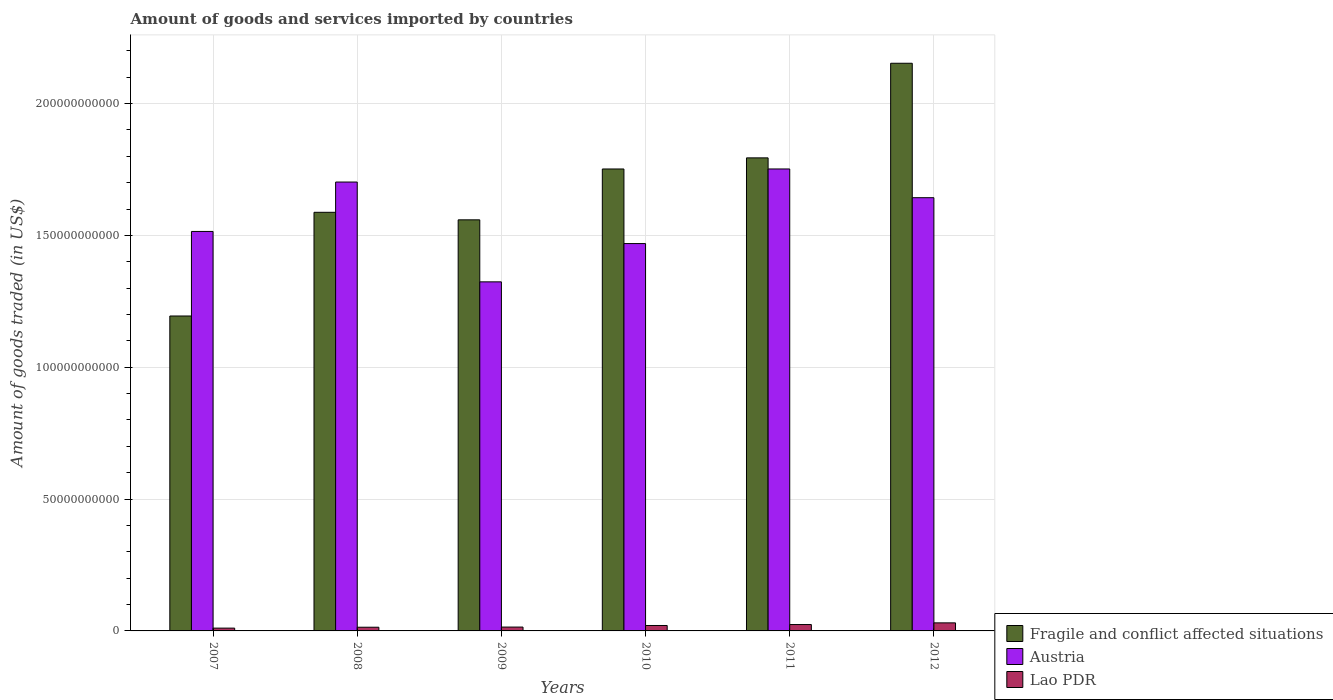How many groups of bars are there?
Make the answer very short. 6. How many bars are there on the 3rd tick from the left?
Provide a short and direct response. 3. What is the label of the 6th group of bars from the left?
Offer a very short reply. 2012. In how many cases, is the number of bars for a given year not equal to the number of legend labels?
Your response must be concise. 0. What is the total amount of goods and services imported in Fragile and conflict affected situations in 2010?
Offer a very short reply. 1.75e+11. Across all years, what is the maximum total amount of goods and services imported in Austria?
Your answer should be very brief. 1.75e+11. Across all years, what is the minimum total amount of goods and services imported in Fragile and conflict affected situations?
Provide a succinct answer. 1.19e+11. In which year was the total amount of goods and services imported in Lao PDR maximum?
Provide a succinct answer. 2012. In which year was the total amount of goods and services imported in Fragile and conflict affected situations minimum?
Make the answer very short. 2007. What is the total total amount of goods and services imported in Fragile and conflict affected situations in the graph?
Offer a very short reply. 1.00e+12. What is the difference between the total amount of goods and services imported in Fragile and conflict affected situations in 2009 and that in 2010?
Make the answer very short. -1.93e+1. What is the difference between the total amount of goods and services imported in Fragile and conflict affected situations in 2011 and the total amount of goods and services imported in Lao PDR in 2010?
Your response must be concise. 1.77e+11. What is the average total amount of goods and services imported in Austria per year?
Your answer should be compact. 1.57e+11. In the year 2012, what is the difference between the total amount of goods and services imported in Lao PDR and total amount of goods and services imported in Fragile and conflict affected situations?
Provide a short and direct response. -2.12e+11. In how many years, is the total amount of goods and services imported in Austria greater than 150000000000 US$?
Keep it short and to the point. 4. What is the ratio of the total amount of goods and services imported in Fragile and conflict affected situations in 2010 to that in 2012?
Your answer should be very brief. 0.81. What is the difference between the highest and the second highest total amount of goods and services imported in Fragile and conflict affected situations?
Your answer should be very brief. 3.59e+1. What is the difference between the highest and the lowest total amount of goods and services imported in Fragile and conflict affected situations?
Your answer should be very brief. 9.59e+1. In how many years, is the total amount of goods and services imported in Austria greater than the average total amount of goods and services imported in Austria taken over all years?
Provide a short and direct response. 3. Is the sum of the total amount of goods and services imported in Fragile and conflict affected situations in 2010 and 2011 greater than the maximum total amount of goods and services imported in Lao PDR across all years?
Offer a terse response. Yes. What does the 2nd bar from the left in 2012 represents?
Keep it short and to the point. Austria. What does the 1st bar from the right in 2009 represents?
Ensure brevity in your answer.  Lao PDR. How many bars are there?
Give a very brief answer. 18. Are the values on the major ticks of Y-axis written in scientific E-notation?
Ensure brevity in your answer.  No. Does the graph contain any zero values?
Your answer should be compact. No. Does the graph contain grids?
Your answer should be compact. Yes. How are the legend labels stacked?
Provide a short and direct response. Vertical. What is the title of the graph?
Keep it short and to the point. Amount of goods and services imported by countries. What is the label or title of the X-axis?
Provide a short and direct response. Years. What is the label or title of the Y-axis?
Give a very brief answer. Amount of goods traded (in US$). What is the Amount of goods traded (in US$) of Fragile and conflict affected situations in 2007?
Offer a terse response. 1.19e+11. What is the Amount of goods traded (in US$) in Austria in 2007?
Your response must be concise. 1.52e+11. What is the Amount of goods traded (in US$) in Lao PDR in 2007?
Your answer should be compact. 1.06e+09. What is the Amount of goods traded (in US$) of Fragile and conflict affected situations in 2008?
Your answer should be very brief. 1.59e+11. What is the Amount of goods traded (in US$) of Austria in 2008?
Make the answer very short. 1.70e+11. What is the Amount of goods traded (in US$) of Lao PDR in 2008?
Give a very brief answer. 1.40e+09. What is the Amount of goods traded (in US$) of Fragile and conflict affected situations in 2009?
Your answer should be very brief. 1.56e+11. What is the Amount of goods traded (in US$) of Austria in 2009?
Your answer should be compact. 1.32e+11. What is the Amount of goods traded (in US$) in Lao PDR in 2009?
Your answer should be compact. 1.46e+09. What is the Amount of goods traded (in US$) of Fragile and conflict affected situations in 2010?
Provide a short and direct response. 1.75e+11. What is the Amount of goods traded (in US$) in Austria in 2010?
Make the answer very short. 1.47e+11. What is the Amount of goods traded (in US$) of Lao PDR in 2010?
Make the answer very short. 2.06e+09. What is the Amount of goods traded (in US$) of Fragile and conflict affected situations in 2011?
Offer a terse response. 1.79e+11. What is the Amount of goods traded (in US$) in Austria in 2011?
Your answer should be compact. 1.75e+11. What is the Amount of goods traded (in US$) in Lao PDR in 2011?
Your answer should be compact. 2.42e+09. What is the Amount of goods traded (in US$) of Fragile and conflict affected situations in 2012?
Offer a terse response. 2.15e+11. What is the Amount of goods traded (in US$) of Austria in 2012?
Your answer should be very brief. 1.64e+11. What is the Amount of goods traded (in US$) in Lao PDR in 2012?
Ensure brevity in your answer.  3.06e+09. Across all years, what is the maximum Amount of goods traded (in US$) in Fragile and conflict affected situations?
Provide a succinct answer. 2.15e+11. Across all years, what is the maximum Amount of goods traded (in US$) in Austria?
Provide a short and direct response. 1.75e+11. Across all years, what is the maximum Amount of goods traded (in US$) of Lao PDR?
Your answer should be compact. 3.06e+09. Across all years, what is the minimum Amount of goods traded (in US$) in Fragile and conflict affected situations?
Keep it short and to the point. 1.19e+11. Across all years, what is the minimum Amount of goods traded (in US$) of Austria?
Provide a short and direct response. 1.32e+11. Across all years, what is the minimum Amount of goods traded (in US$) in Lao PDR?
Make the answer very short. 1.06e+09. What is the total Amount of goods traded (in US$) of Fragile and conflict affected situations in the graph?
Give a very brief answer. 1.00e+12. What is the total Amount of goods traded (in US$) in Austria in the graph?
Offer a very short reply. 9.41e+11. What is the total Amount of goods traded (in US$) of Lao PDR in the graph?
Keep it short and to the point. 1.15e+1. What is the difference between the Amount of goods traded (in US$) in Fragile and conflict affected situations in 2007 and that in 2008?
Keep it short and to the point. -3.93e+1. What is the difference between the Amount of goods traded (in US$) in Austria in 2007 and that in 2008?
Your response must be concise. -1.87e+1. What is the difference between the Amount of goods traded (in US$) of Lao PDR in 2007 and that in 2008?
Offer a terse response. -3.39e+08. What is the difference between the Amount of goods traded (in US$) of Fragile and conflict affected situations in 2007 and that in 2009?
Make the answer very short. -3.65e+1. What is the difference between the Amount of goods traded (in US$) in Austria in 2007 and that in 2009?
Your response must be concise. 1.91e+1. What is the difference between the Amount of goods traded (in US$) of Lao PDR in 2007 and that in 2009?
Give a very brief answer. -3.96e+08. What is the difference between the Amount of goods traded (in US$) in Fragile and conflict affected situations in 2007 and that in 2010?
Your answer should be very brief. -5.58e+1. What is the difference between the Amount of goods traded (in US$) in Austria in 2007 and that in 2010?
Ensure brevity in your answer.  4.60e+09. What is the difference between the Amount of goods traded (in US$) of Lao PDR in 2007 and that in 2010?
Offer a very short reply. -9.96e+08. What is the difference between the Amount of goods traded (in US$) in Fragile and conflict affected situations in 2007 and that in 2011?
Ensure brevity in your answer.  -6.00e+1. What is the difference between the Amount of goods traded (in US$) in Austria in 2007 and that in 2011?
Offer a terse response. -2.37e+1. What is the difference between the Amount of goods traded (in US$) of Lao PDR in 2007 and that in 2011?
Give a very brief answer. -1.36e+09. What is the difference between the Amount of goods traded (in US$) in Fragile and conflict affected situations in 2007 and that in 2012?
Your answer should be compact. -9.59e+1. What is the difference between the Amount of goods traded (in US$) in Austria in 2007 and that in 2012?
Keep it short and to the point. -1.28e+1. What is the difference between the Amount of goods traded (in US$) in Lao PDR in 2007 and that in 2012?
Ensure brevity in your answer.  -1.99e+09. What is the difference between the Amount of goods traded (in US$) of Fragile and conflict affected situations in 2008 and that in 2009?
Provide a short and direct response. 2.86e+09. What is the difference between the Amount of goods traded (in US$) of Austria in 2008 and that in 2009?
Make the answer very short. 3.79e+1. What is the difference between the Amount of goods traded (in US$) in Lao PDR in 2008 and that in 2009?
Keep it short and to the point. -5.79e+07. What is the difference between the Amount of goods traded (in US$) of Fragile and conflict affected situations in 2008 and that in 2010?
Your answer should be compact. -1.64e+1. What is the difference between the Amount of goods traded (in US$) of Austria in 2008 and that in 2010?
Your response must be concise. 2.33e+1. What is the difference between the Amount of goods traded (in US$) in Lao PDR in 2008 and that in 2010?
Provide a short and direct response. -6.57e+08. What is the difference between the Amount of goods traded (in US$) of Fragile and conflict affected situations in 2008 and that in 2011?
Offer a terse response. -2.06e+1. What is the difference between the Amount of goods traded (in US$) in Austria in 2008 and that in 2011?
Ensure brevity in your answer.  -4.96e+09. What is the difference between the Amount of goods traded (in US$) in Lao PDR in 2008 and that in 2011?
Give a very brief answer. -1.02e+09. What is the difference between the Amount of goods traded (in US$) in Fragile and conflict affected situations in 2008 and that in 2012?
Give a very brief answer. -5.65e+1. What is the difference between the Amount of goods traded (in US$) of Austria in 2008 and that in 2012?
Make the answer very short. 5.94e+09. What is the difference between the Amount of goods traded (in US$) of Lao PDR in 2008 and that in 2012?
Give a very brief answer. -1.65e+09. What is the difference between the Amount of goods traded (in US$) in Fragile and conflict affected situations in 2009 and that in 2010?
Provide a short and direct response. -1.93e+1. What is the difference between the Amount of goods traded (in US$) of Austria in 2009 and that in 2010?
Offer a very short reply. -1.45e+1. What is the difference between the Amount of goods traded (in US$) in Lao PDR in 2009 and that in 2010?
Offer a terse response. -5.99e+08. What is the difference between the Amount of goods traded (in US$) of Fragile and conflict affected situations in 2009 and that in 2011?
Provide a short and direct response. -2.35e+1. What is the difference between the Amount of goods traded (in US$) in Austria in 2009 and that in 2011?
Your answer should be very brief. -4.28e+1. What is the difference between the Amount of goods traded (in US$) in Lao PDR in 2009 and that in 2011?
Ensure brevity in your answer.  -9.62e+08. What is the difference between the Amount of goods traded (in US$) of Fragile and conflict affected situations in 2009 and that in 2012?
Provide a short and direct response. -5.94e+1. What is the difference between the Amount of goods traded (in US$) of Austria in 2009 and that in 2012?
Provide a succinct answer. -3.19e+1. What is the difference between the Amount of goods traded (in US$) of Lao PDR in 2009 and that in 2012?
Make the answer very short. -1.59e+09. What is the difference between the Amount of goods traded (in US$) of Fragile and conflict affected situations in 2010 and that in 2011?
Give a very brief answer. -4.21e+09. What is the difference between the Amount of goods traded (in US$) in Austria in 2010 and that in 2011?
Provide a short and direct response. -2.83e+1. What is the difference between the Amount of goods traded (in US$) of Lao PDR in 2010 and that in 2011?
Give a very brief answer. -3.62e+08. What is the difference between the Amount of goods traded (in US$) in Fragile and conflict affected situations in 2010 and that in 2012?
Your response must be concise. -4.01e+1. What is the difference between the Amount of goods traded (in US$) in Austria in 2010 and that in 2012?
Provide a short and direct response. -1.74e+1. What is the difference between the Amount of goods traded (in US$) of Lao PDR in 2010 and that in 2012?
Make the answer very short. -9.95e+08. What is the difference between the Amount of goods traded (in US$) of Fragile and conflict affected situations in 2011 and that in 2012?
Make the answer very short. -3.59e+1. What is the difference between the Amount of goods traded (in US$) in Austria in 2011 and that in 2012?
Your answer should be very brief. 1.09e+1. What is the difference between the Amount of goods traded (in US$) of Lao PDR in 2011 and that in 2012?
Keep it short and to the point. -6.32e+08. What is the difference between the Amount of goods traded (in US$) of Fragile and conflict affected situations in 2007 and the Amount of goods traded (in US$) of Austria in 2008?
Offer a terse response. -5.08e+1. What is the difference between the Amount of goods traded (in US$) in Fragile and conflict affected situations in 2007 and the Amount of goods traded (in US$) in Lao PDR in 2008?
Your response must be concise. 1.18e+11. What is the difference between the Amount of goods traded (in US$) in Austria in 2007 and the Amount of goods traded (in US$) in Lao PDR in 2008?
Offer a very short reply. 1.50e+11. What is the difference between the Amount of goods traded (in US$) of Fragile and conflict affected situations in 2007 and the Amount of goods traded (in US$) of Austria in 2009?
Provide a succinct answer. -1.29e+1. What is the difference between the Amount of goods traded (in US$) in Fragile and conflict affected situations in 2007 and the Amount of goods traded (in US$) in Lao PDR in 2009?
Keep it short and to the point. 1.18e+11. What is the difference between the Amount of goods traded (in US$) in Austria in 2007 and the Amount of goods traded (in US$) in Lao PDR in 2009?
Give a very brief answer. 1.50e+11. What is the difference between the Amount of goods traded (in US$) in Fragile and conflict affected situations in 2007 and the Amount of goods traded (in US$) in Austria in 2010?
Keep it short and to the point. -2.75e+1. What is the difference between the Amount of goods traded (in US$) of Fragile and conflict affected situations in 2007 and the Amount of goods traded (in US$) of Lao PDR in 2010?
Your answer should be compact. 1.17e+11. What is the difference between the Amount of goods traded (in US$) in Austria in 2007 and the Amount of goods traded (in US$) in Lao PDR in 2010?
Your answer should be compact. 1.49e+11. What is the difference between the Amount of goods traded (in US$) in Fragile and conflict affected situations in 2007 and the Amount of goods traded (in US$) in Austria in 2011?
Give a very brief answer. -5.58e+1. What is the difference between the Amount of goods traded (in US$) of Fragile and conflict affected situations in 2007 and the Amount of goods traded (in US$) of Lao PDR in 2011?
Your response must be concise. 1.17e+11. What is the difference between the Amount of goods traded (in US$) in Austria in 2007 and the Amount of goods traded (in US$) in Lao PDR in 2011?
Offer a terse response. 1.49e+11. What is the difference between the Amount of goods traded (in US$) of Fragile and conflict affected situations in 2007 and the Amount of goods traded (in US$) of Austria in 2012?
Offer a very short reply. -4.49e+1. What is the difference between the Amount of goods traded (in US$) in Fragile and conflict affected situations in 2007 and the Amount of goods traded (in US$) in Lao PDR in 2012?
Ensure brevity in your answer.  1.16e+11. What is the difference between the Amount of goods traded (in US$) in Austria in 2007 and the Amount of goods traded (in US$) in Lao PDR in 2012?
Make the answer very short. 1.48e+11. What is the difference between the Amount of goods traded (in US$) in Fragile and conflict affected situations in 2008 and the Amount of goods traded (in US$) in Austria in 2009?
Your answer should be compact. 2.64e+1. What is the difference between the Amount of goods traded (in US$) in Fragile and conflict affected situations in 2008 and the Amount of goods traded (in US$) in Lao PDR in 2009?
Offer a terse response. 1.57e+11. What is the difference between the Amount of goods traded (in US$) of Austria in 2008 and the Amount of goods traded (in US$) of Lao PDR in 2009?
Make the answer very short. 1.69e+11. What is the difference between the Amount of goods traded (in US$) of Fragile and conflict affected situations in 2008 and the Amount of goods traded (in US$) of Austria in 2010?
Provide a succinct answer. 1.19e+1. What is the difference between the Amount of goods traded (in US$) of Fragile and conflict affected situations in 2008 and the Amount of goods traded (in US$) of Lao PDR in 2010?
Provide a succinct answer. 1.57e+11. What is the difference between the Amount of goods traded (in US$) of Austria in 2008 and the Amount of goods traded (in US$) of Lao PDR in 2010?
Your answer should be compact. 1.68e+11. What is the difference between the Amount of goods traded (in US$) of Fragile and conflict affected situations in 2008 and the Amount of goods traded (in US$) of Austria in 2011?
Provide a short and direct response. -1.64e+1. What is the difference between the Amount of goods traded (in US$) of Fragile and conflict affected situations in 2008 and the Amount of goods traded (in US$) of Lao PDR in 2011?
Provide a short and direct response. 1.56e+11. What is the difference between the Amount of goods traded (in US$) of Austria in 2008 and the Amount of goods traded (in US$) of Lao PDR in 2011?
Your response must be concise. 1.68e+11. What is the difference between the Amount of goods traded (in US$) of Fragile and conflict affected situations in 2008 and the Amount of goods traded (in US$) of Austria in 2012?
Offer a very short reply. -5.54e+09. What is the difference between the Amount of goods traded (in US$) in Fragile and conflict affected situations in 2008 and the Amount of goods traded (in US$) in Lao PDR in 2012?
Offer a very short reply. 1.56e+11. What is the difference between the Amount of goods traded (in US$) of Austria in 2008 and the Amount of goods traded (in US$) of Lao PDR in 2012?
Give a very brief answer. 1.67e+11. What is the difference between the Amount of goods traded (in US$) of Fragile and conflict affected situations in 2009 and the Amount of goods traded (in US$) of Austria in 2010?
Provide a short and direct response. 9.01e+09. What is the difference between the Amount of goods traded (in US$) of Fragile and conflict affected situations in 2009 and the Amount of goods traded (in US$) of Lao PDR in 2010?
Make the answer very short. 1.54e+11. What is the difference between the Amount of goods traded (in US$) in Austria in 2009 and the Amount of goods traded (in US$) in Lao PDR in 2010?
Your answer should be compact. 1.30e+11. What is the difference between the Amount of goods traded (in US$) of Fragile and conflict affected situations in 2009 and the Amount of goods traded (in US$) of Austria in 2011?
Keep it short and to the point. -1.93e+1. What is the difference between the Amount of goods traded (in US$) in Fragile and conflict affected situations in 2009 and the Amount of goods traded (in US$) in Lao PDR in 2011?
Offer a terse response. 1.53e+11. What is the difference between the Amount of goods traded (in US$) of Austria in 2009 and the Amount of goods traded (in US$) of Lao PDR in 2011?
Make the answer very short. 1.30e+11. What is the difference between the Amount of goods traded (in US$) in Fragile and conflict affected situations in 2009 and the Amount of goods traded (in US$) in Austria in 2012?
Give a very brief answer. -8.39e+09. What is the difference between the Amount of goods traded (in US$) in Fragile and conflict affected situations in 2009 and the Amount of goods traded (in US$) in Lao PDR in 2012?
Your response must be concise. 1.53e+11. What is the difference between the Amount of goods traded (in US$) in Austria in 2009 and the Amount of goods traded (in US$) in Lao PDR in 2012?
Your answer should be very brief. 1.29e+11. What is the difference between the Amount of goods traded (in US$) in Fragile and conflict affected situations in 2010 and the Amount of goods traded (in US$) in Austria in 2011?
Your answer should be very brief. -6.64e+06. What is the difference between the Amount of goods traded (in US$) in Fragile and conflict affected situations in 2010 and the Amount of goods traded (in US$) in Lao PDR in 2011?
Provide a short and direct response. 1.73e+11. What is the difference between the Amount of goods traded (in US$) of Austria in 2010 and the Amount of goods traded (in US$) of Lao PDR in 2011?
Your answer should be compact. 1.44e+11. What is the difference between the Amount of goods traded (in US$) in Fragile and conflict affected situations in 2010 and the Amount of goods traded (in US$) in Austria in 2012?
Your response must be concise. 1.09e+1. What is the difference between the Amount of goods traded (in US$) in Fragile and conflict affected situations in 2010 and the Amount of goods traded (in US$) in Lao PDR in 2012?
Give a very brief answer. 1.72e+11. What is the difference between the Amount of goods traded (in US$) of Austria in 2010 and the Amount of goods traded (in US$) of Lao PDR in 2012?
Keep it short and to the point. 1.44e+11. What is the difference between the Amount of goods traded (in US$) of Fragile and conflict affected situations in 2011 and the Amount of goods traded (in US$) of Austria in 2012?
Offer a terse response. 1.51e+1. What is the difference between the Amount of goods traded (in US$) of Fragile and conflict affected situations in 2011 and the Amount of goods traded (in US$) of Lao PDR in 2012?
Offer a very short reply. 1.76e+11. What is the difference between the Amount of goods traded (in US$) of Austria in 2011 and the Amount of goods traded (in US$) of Lao PDR in 2012?
Provide a short and direct response. 1.72e+11. What is the average Amount of goods traded (in US$) in Fragile and conflict affected situations per year?
Provide a short and direct response. 1.67e+11. What is the average Amount of goods traded (in US$) of Austria per year?
Provide a succinct answer. 1.57e+11. What is the average Amount of goods traded (in US$) in Lao PDR per year?
Provide a succinct answer. 1.91e+09. In the year 2007, what is the difference between the Amount of goods traded (in US$) in Fragile and conflict affected situations and Amount of goods traded (in US$) in Austria?
Ensure brevity in your answer.  -3.21e+1. In the year 2007, what is the difference between the Amount of goods traded (in US$) in Fragile and conflict affected situations and Amount of goods traded (in US$) in Lao PDR?
Offer a terse response. 1.18e+11. In the year 2007, what is the difference between the Amount of goods traded (in US$) in Austria and Amount of goods traded (in US$) in Lao PDR?
Your answer should be very brief. 1.50e+11. In the year 2008, what is the difference between the Amount of goods traded (in US$) in Fragile and conflict affected situations and Amount of goods traded (in US$) in Austria?
Your response must be concise. -1.15e+1. In the year 2008, what is the difference between the Amount of goods traded (in US$) in Fragile and conflict affected situations and Amount of goods traded (in US$) in Lao PDR?
Offer a terse response. 1.57e+11. In the year 2008, what is the difference between the Amount of goods traded (in US$) in Austria and Amount of goods traded (in US$) in Lao PDR?
Provide a short and direct response. 1.69e+11. In the year 2009, what is the difference between the Amount of goods traded (in US$) in Fragile and conflict affected situations and Amount of goods traded (in US$) in Austria?
Make the answer very short. 2.35e+1. In the year 2009, what is the difference between the Amount of goods traded (in US$) of Fragile and conflict affected situations and Amount of goods traded (in US$) of Lao PDR?
Make the answer very short. 1.54e+11. In the year 2009, what is the difference between the Amount of goods traded (in US$) in Austria and Amount of goods traded (in US$) in Lao PDR?
Your answer should be very brief. 1.31e+11. In the year 2010, what is the difference between the Amount of goods traded (in US$) of Fragile and conflict affected situations and Amount of goods traded (in US$) of Austria?
Provide a succinct answer. 2.83e+1. In the year 2010, what is the difference between the Amount of goods traded (in US$) in Fragile and conflict affected situations and Amount of goods traded (in US$) in Lao PDR?
Provide a succinct answer. 1.73e+11. In the year 2010, what is the difference between the Amount of goods traded (in US$) of Austria and Amount of goods traded (in US$) of Lao PDR?
Keep it short and to the point. 1.45e+11. In the year 2011, what is the difference between the Amount of goods traded (in US$) in Fragile and conflict affected situations and Amount of goods traded (in US$) in Austria?
Give a very brief answer. 4.21e+09. In the year 2011, what is the difference between the Amount of goods traded (in US$) in Fragile and conflict affected situations and Amount of goods traded (in US$) in Lao PDR?
Your response must be concise. 1.77e+11. In the year 2011, what is the difference between the Amount of goods traded (in US$) of Austria and Amount of goods traded (in US$) of Lao PDR?
Ensure brevity in your answer.  1.73e+11. In the year 2012, what is the difference between the Amount of goods traded (in US$) in Fragile and conflict affected situations and Amount of goods traded (in US$) in Austria?
Provide a succinct answer. 5.10e+1. In the year 2012, what is the difference between the Amount of goods traded (in US$) of Fragile and conflict affected situations and Amount of goods traded (in US$) of Lao PDR?
Your response must be concise. 2.12e+11. In the year 2012, what is the difference between the Amount of goods traded (in US$) of Austria and Amount of goods traded (in US$) of Lao PDR?
Your answer should be very brief. 1.61e+11. What is the ratio of the Amount of goods traded (in US$) in Fragile and conflict affected situations in 2007 to that in 2008?
Offer a terse response. 0.75. What is the ratio of the Amount of goods traded (in US$) in Austria in 2007 to that in 2008?
Keep it short and to the point. 0.89. What is the ratio of the Amount of goods traded (in US$) of Lao PDR in 2007 to that in 2008?
Give a very brief answer. 0.76. What is the ratio of the Amount of goods traded (in US$) in Fragile and conflict affected situations in 2007 to that in 2009?
Your response must be concise. 0.77. What is the ratio of the Amount of goods traded (in US$) of Austria in 2007 to that in 2009?
Give a very brief answer. 1.14. What is the ratio of the Amount of goods traded (in US$) in Lao PDR in 2007 to that in 2009?
Ensure brevity in your answer.  0.73. What is the ratio of the Amount of goods traded (in US$) of Fragile and conflict affected situations in 2007 to that in 2010?
Give a very brief answer. 0.68. What is the ratio of the Amount of goods traded (in US$) of Austria in 2007 to that in 2010?
Your answer should be compact. 1.03. What is the ratio of the Amount of goods traded (in US$) of Lao PDR in 2007 to that in 2010?
Your answer should be very brief. 0.52. What is the ratio of the Amount of goods traded (in US$) in Fragile and conflict affected situations in 2007 to that in 2011?
Your answer should be compact. 0.67. What is the ratio of the Amount of goods traded (in US$) in Austria in 2007 to that in 2011?
Your answer should be compact. 0.86. What is the ratio of the Amount of goods traded (in US$) in Lao PDR in 2007 to that in 2011?
Provide a succinct answer. 0.44. What is the ratio of the Amount of goods traded (in US$) in Fragile and conflict affected situations in 2007 to that in 2012?
Give a very brief answer. 0.55. What is the ratio of the Amount of goods traded (in US$) in Austria in 2007 to that in 2012?
Make the answer very short. 0.92. What is the ratio of the Amount of goods traded (in US$) of Lao PDR in 2007 to that in 2012?
Your response must be concise. 0.35. What is the ratio of the Amount of goods traded (in US$) in Fragile and conflict affected situations in 2008 to that in 2009?
Give a very brief answer. 1.02. What is the ratio of the Amount of goods traded (in US$) of Austria in 2008 to that in 2009?
Offer a terse response. 1.29. What is the ratio of the Amount of goods traded (in US$) of Lao PDR in 2008 to that in 2009?
Provide a short and direct response. 0.96. What is the ratio of the Amount of goods traded (in US$) of Fragile and conflict affected situations in 2008 to that in 2010?
Offer a very short reply. 0.91. What is the ratio of the Amount of goods traded (in US$) in Austria in 2008 to that in 2010?
Ensure brevity in your answer.  1.16. What is the ratio of the Amount of goods traded (in US$) in Lao PDR in 2008 to that in 2010?
Make the answer very short. 0.68. What is the ratio of the Amount of goods traded (in US$) of Fragile and conflict affected situations in 2008 to that in 2011?
Make the answer very short. 0.88. What is the ratio of the Amount of goods traded (in US$) in Austria in 2008 to that in 2011?
Provide a succinct answer. 0.97. What is the ratio of the Amount of goods traded (in US$) of Lao PDR in 2008 to that in 2011?
Ensure brevity in your answer.  0.58. What is the ratio of the Amount of goods traded (in US$) in Fragile and conflict affected situations in 2008 to that in 2012?
Ensure brevity in your answer.  0.74. What is the ratio of the Amount of goods traded (in US$) of Austria in 2008 to that in 2012?
Give a very brief answer. 1.04. What is the ratio of the Amount of goods traded (in US$) in Lao PDR in 2008 to that in 2012?
Offer a very short reply. 0.46. What is the ratio of the Amount of goods traded (in US$) of Fragile and conflict affected situations in 2009 to that in 2010?
Your answer should be very brief. 0.89. What is the ratio of the Amount of goods traded (in US$) in Austria in 2009 to that in 2010?
Provide a succinct answer. 0.9. What is the ratio of the Amount of goods traded (in US$) of Lao PDR in 2009 to that in 2010?
Your response must be concise. 0.71. What is the ratio of the Amount of goods traded (in US$) in Fragile and conflict affected situations in 2009 to that in 2011?
Provide a succinct answer. 0.87. What is the ratio of the Amount of goods traded (in US$) of Austria in 2009 to that in 2011?
Keep it short and to the point. 0.76. What is the ratio of the Amount of goods traded (in US$) of Lao PDR in 2009 to that in 2011?
Provide a succinct answer. 0.6. What is the ratio of the Amount of goods traded (in US$) of Fragile and conflict affected situations in 2009 to that in 2012?
Provide a succinct answer. 0.72. What is the ratio of the Amount of goods traded (in US$) of Austria in 2009 to that in 2012?
Give a very brief answer. 0.81. What is the ratio of the Amount of goods traded (in US$) of Lao PDR in 2009 to that in 2012?
Your response must be concise. 0.48. What is the ratio of the Amount of goods traded (in US$) in Fragile and conflict affected situations in 2010 to that in 2011?
Make the answer very short. 0.98. What is the ratio of the Amount of goods traded (in US$) of Austria in 2010 to that in 2011?
Offer a very short reply. 0.84. What is the ratio of the Amount of goods traded (in US$) of Lao PDR in 2010 to that in 2011?
Keep it short and to the point. 0.85. What is the ratio of the Amount of goods traded (in US$) in Fragile and conflict affected situations in 2010 to that in 2012?
Your answer should be compact. 0.81. What is the ratio of the Amount of goods traded (in US$) in Austria in 2010 to that in 2012?
Your response must be concise. 0.89. What is the ratio of the Amount of goods traded (in US$) in Lao PDR in 2010 to that in 2012?
Give a very brief answer. 0.67. What is the ratio of the Amount of goods traded (in US$) of Fragile and conflict affected situations in 2011 to that in 2012?
Provide a succinct answer. 0.83. What is the ratio of the Amount of goods traded (in US$) in Austria in 2011 to that in 2012?
Ensure brevity in your answer.  1.07. What is the ratio of the Amount of goods traded (in US$) of Lao PDR in 2011 to that in 2012?
Give a very brief answer. 0.79. What is the difference between the highest and the second highest Amount of goods traded (in US$) in Fragile and conflict affected situations?
Your answer should be very brief. 3.59e+1. What is the difference between the highest and the second highest Amount of goods traded (in US$) in Austria?
Provide a succinct answer. 4.96e+09. What is the difference between the highest and the second highest Amount of goods traded (in US$) in Lao PDR?
Your response must be concise. 6.32e+08. What is the difference between the highest and the lowest Amount of goods traded (in US$) of Fragile and conflict affected situations?
Your answer should be compact. 9.59e+1. What is the difference between the highest and the lowest Amount of goods traded (in US$) in Austria?
Make the answer very short. 4.28e+1. What is the difference between the highest and the lowest Amount of goods traded (in US$) in Lao PDR?
Your answer should be very brief. 1.99e+09. 